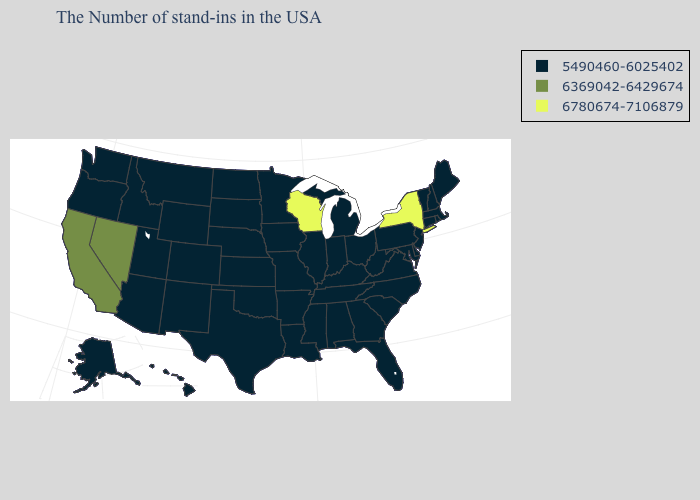Name the states that have a value in the range 5490460-6025402?
Quick response, please. Maine, Massachusetts, Rhode Island, New Hampshire, Vermont, Connecticut, New Jersey, Delaware, Maryland, Pennsylvania, Virginia, North Carolina, South Carolina, West Virginia, Ohio, Florida, Georgia, Michigan, Kentucky, Indiana, Alabama, Tennessee, Illinois, Mississippi, Louisiana, Missouri, Arkansas, Minnesota, Iowa, Kansas, Nebraska, Oklahoma, Texas, South Dakota, North Dakota, Wyoming, Colorado, New Mexico, Utah, Montana, Arizona, Idaho, Washington, Oregon, Alaska, Hawaii. Does California have the highest value in the West?
Give a very brief answer. Yes. Among the states that border Michigan , which have the highest value?
Quick response, please. Wisconsin. What is the highest value in states that border Colorado?
Write a very short answer. 5490460-6025402. What is the value of Maine?
Quick response, please. 5490460-6025402. Does Nevada have the lowest value in the West?
Short answer required. No. Does Kansas have a lower value than New Hampshire?
Keep it brief. No. Which states have the lowest value in the USA?
Be succinct. Maine, Massachusetts, Rhode Island, New Hampshire, Vermont, Connecticut, New Jersey, Delaware, Maryland, Pennsylvania, Virginia, North Carolina, South Carolina, West Virginia, Ohio, Florida, Georgia, Michigan, Kentucky, Indiana, Alabama, Tennessee, Illinois, Mississippi, Louisiana, Missouri, Arkansas, Minnesota, Iowa, Kansas, Nebraska, Oklahoma, Texas, South Dakota, North Dakota, Wyoming, Colorado, New Mexico, Utah, Montana, Arizona, Idaho, Washington, Oregon, Alaska, Hawaii. Among the states that border Virginia , which have the lowest value?
Write a very short answer. Maryland, North Carolina, West Virginia, Kentucky, Tennessee. Does Tennessee have a lower value than Connecticut?
Give a very brief answer. No. Which states have the lowest value in the USA?
Answer briefly. Maine, Massachusetts, Rhode Island, New Hampshire, Vermont, Connecticut, New Jersey, Delaware, Maryland, Pennsylvania, Virginia, North Carolina, South Carolina, West Virginia, Ohio, Florida, Georgia, Michigan, Kentucky, Indiana, Alabama, Tennessee, Illinois, Mississippi, Louisiana, Missouri, Arkansas, Minnesota, Iowa, Kansas, Nebraska, Oklahoma, Texas, South Dakota, North Dakota, Wyoming, Colorado, New Mexico, Utah, Montana, Arizona, Idaho, Washington, Oregon, Alaska, Hawaii. Which states have the lowest value in the MidWest?
Give a very brief answer. Ohio, Michigan, Indiana, Illinois, Missouri, Minnesota, Iowa, Kansas, Nebraska, South Dakota, North Dakota. Among the states that border Wisconsin , which have the lowest value?
Keep it brief. Michigan, Illinois, Minnesota, Iowa. Name the states that have a value in the range 6369042-6429674?
Concise answer only. Nevada, California. What is the lowest value in states that border Arizona?
Concise answer only. 5490460-6025402. 